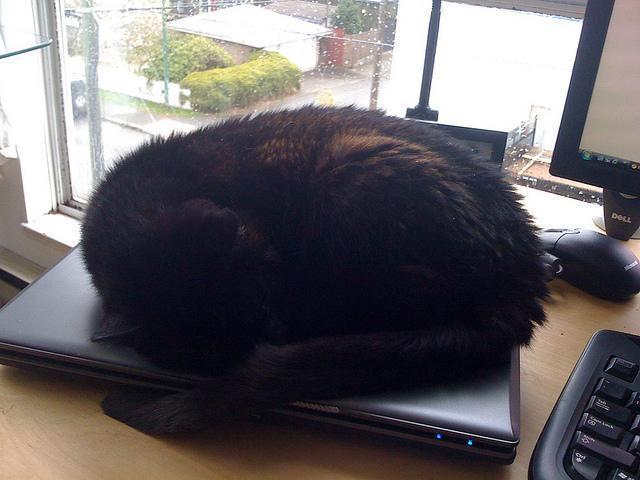How many keyboards are visible?
Give a very brief answer. 1. How many donuts are on display?
Give a very brief answer. 0. 